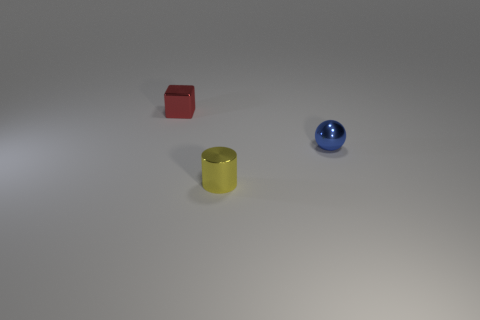Is the number of objects in front of the small ball greater than the number of big brown objects?
Your response must be concise. Yes. What color is the cube that is the same size as the yellow cylinder?
Offer a very short reply. Red. What number of objects are either things in front of the tiny red metallic cube or blue rubber things?
Provide a short and direct response. 2. What is the small thing that is behind the tiny object that is on the right side of the yellow shiny object made of?
Ensure brevity in your answer.  Metal. Is there another yellow cylinder made of the same material as the cylinder?
Provide a succinct answer. No. Is there a tiny yellow cylinder in front of the metal object left of the cylinder?
Provide a short and direct response. Yes. Is the tiny yellow metal thing the same shape as the blue thing?
Make the answer very short. No. What is the color of the shiny object behind the metal object that is right of the tiny shiny thing in front of the sphere?
Keep it short and to the point. Red. There is a thing behind the small sphere that is behind the tiny yellow metallic object; are there any tiny metallic things to the left of it?
Offer a very short reply. No. How big is the red metal block?
Provide a short and direct response. Small. 